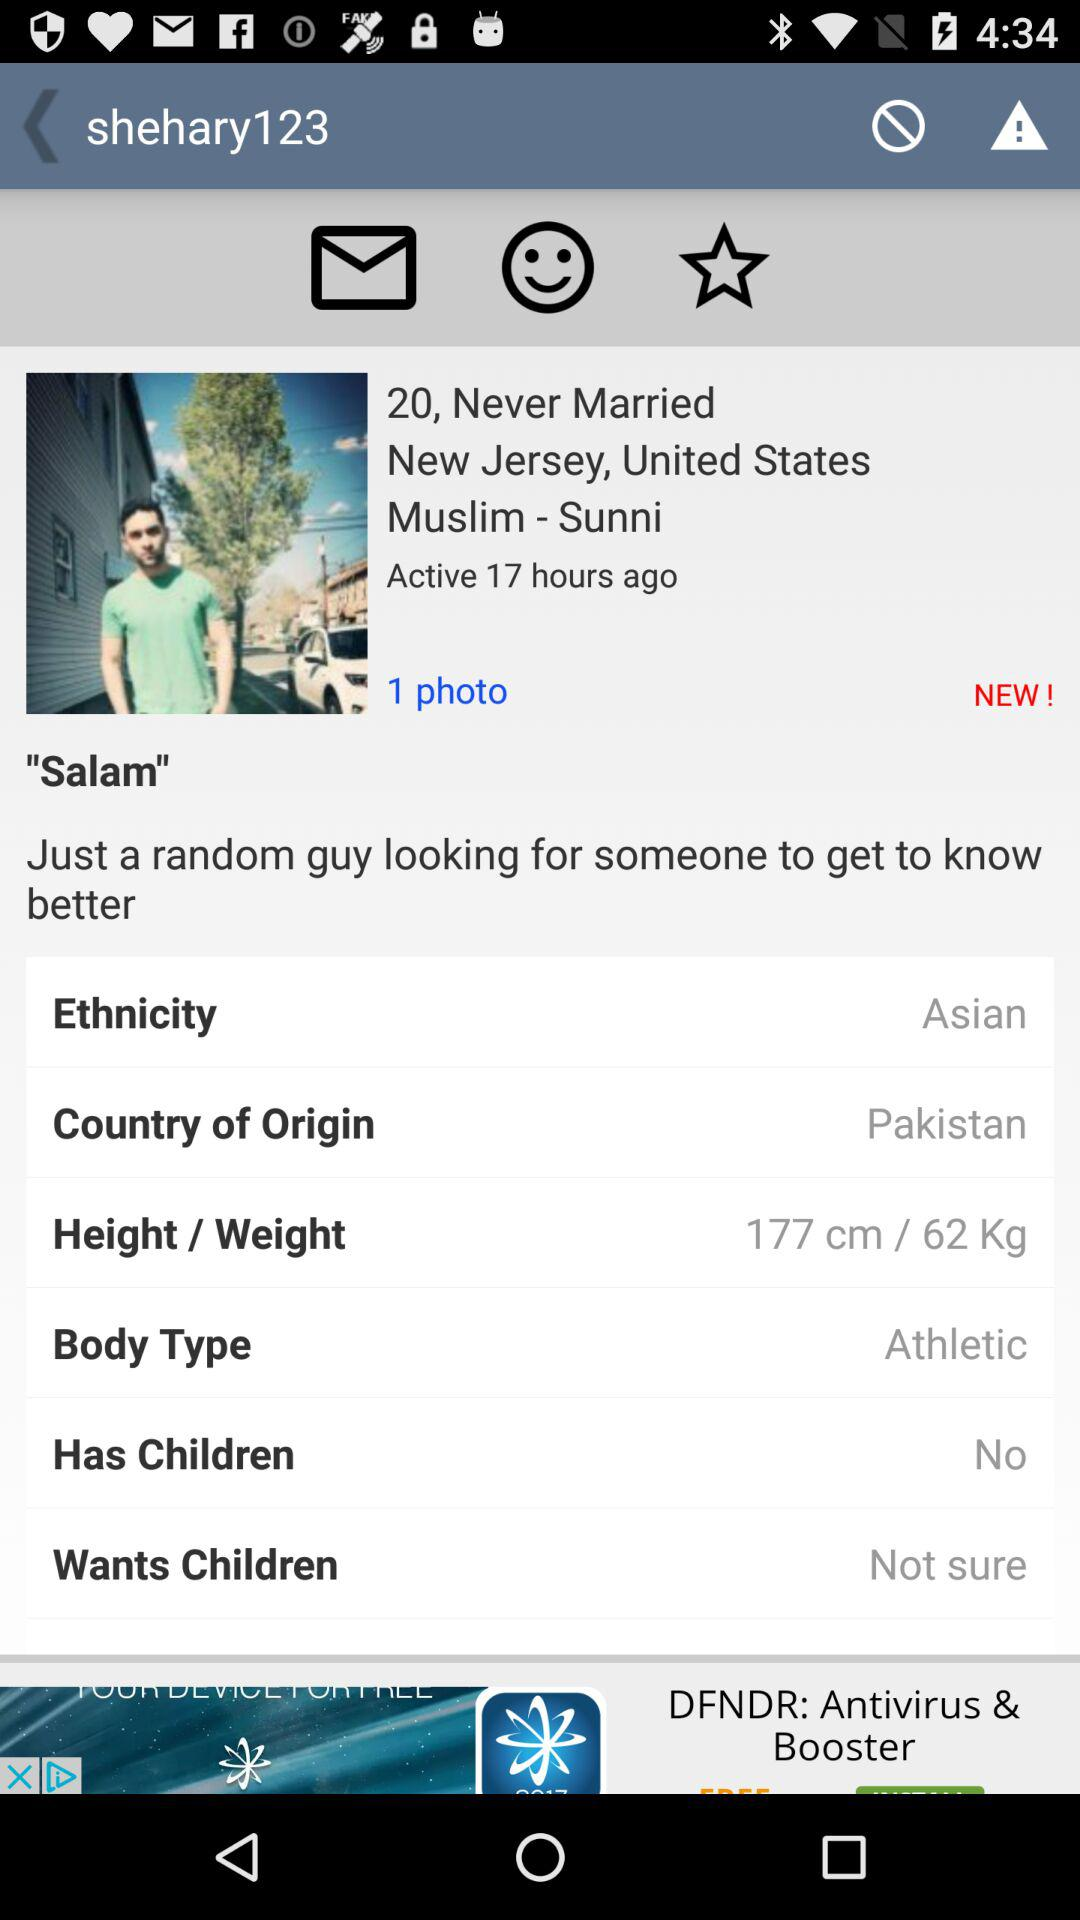What is the age of shehary123? The age is 20 years old. 